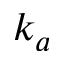<formula> <loc_0><loc_0><loc_500><loc_500>k _ { a }</formula> 